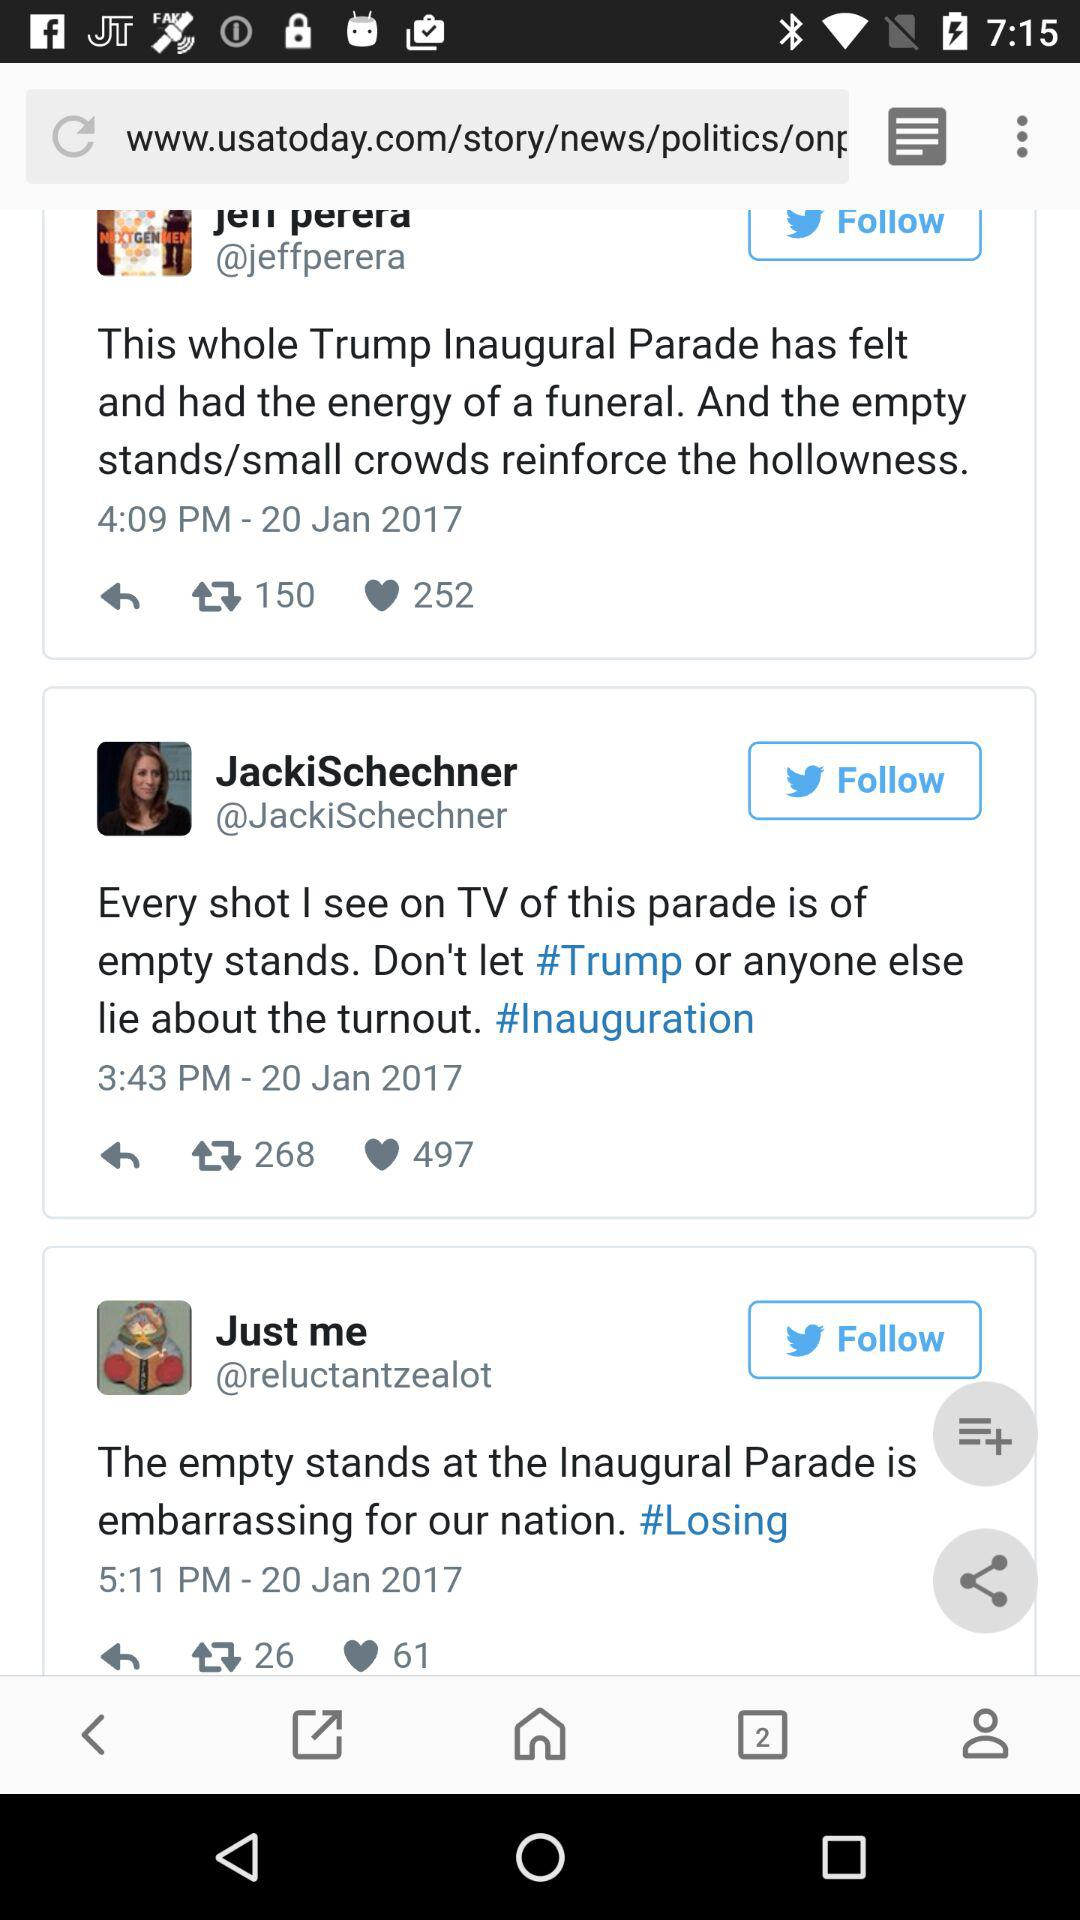How many people have liked JackiSchechner's post? The number of people who have liked JackiSchechner's post is 497. 